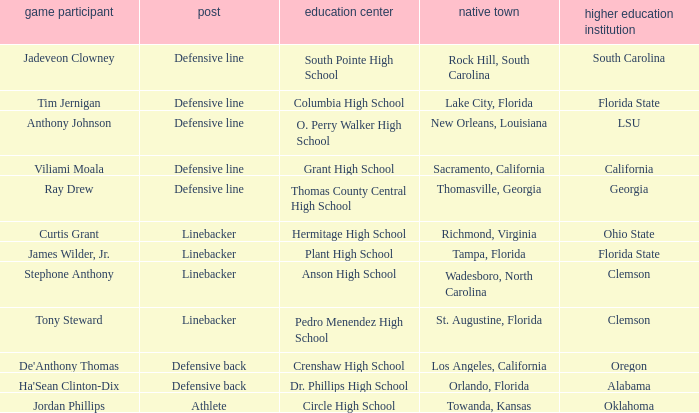What college has a position of defensive line and Grant high school? California. 